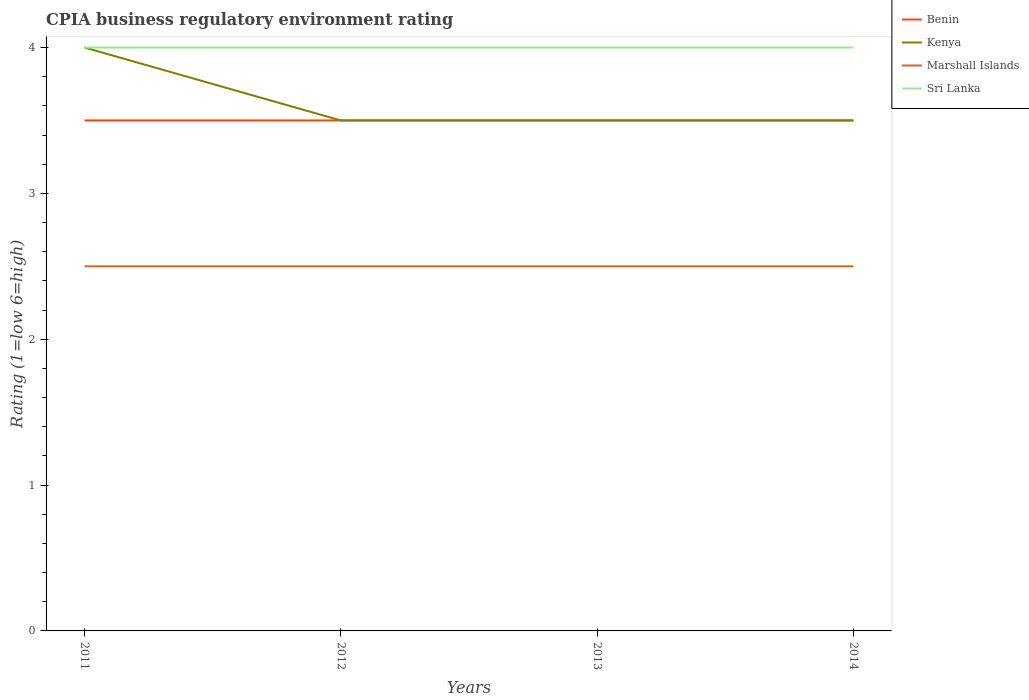How many different coloured lines are there?
Provide a succinct answer. 4. Is the number of lines equal to the number of legend labels?
Make the answer very short. Yes. Across all years, what is the maximum CPIA rating in Benin?
Offer a terse response. 3.5. What is the total CPIA rating in Marshall Islands in the graph?
Offer a very short reply. 0. How many years are there in the graph?
Provide a succinct answer. 4. Are the values on the major ticks of Y-axis written in scientific E-notation?
Ensure brevity in your answer.  No. Does the graph contain grids?
Give a very brief answer. No. How many legend labels are there?
Provide a succinct answer. 4. How are the legend labels stacked?
Offer a terse response. Vertical. What is the title of the graph?
Give a very brief answer. CPIA business regulatory environment rating. Does "Finland" appear as one of the legend labels in the graph?
Give a very brief answer. No. What is the Rating (1=low 6=high) in Benin in 2011?
Keep it short and to the point. 3.5. What is the Rating (1=low 6=high) of Kenya in 2011?
Your answer should be very brief. 4. What is the Rating (1=low 6=high) of Kenya in 2012?
Give a very brief answer. 3.5. What is the Rating (1=low 6=high) of Marshall Islands in 2012?
Give a very brief answer. 2.5. What is the Rating (1=low 6=high) in Marshall Islands in 2013?
Ensure brevity in your answer.  2.5. What is the Rating (1=low 6=high) of Sri Lanka in 2013?
Your answer should be very brief. 4. What is the Rating (1=low 6=high) of Marshall Islands in 2014?
Keep it short and to the point. 2.5. Across all years, what is the maximum Rating (1=low 6=high) in Benin?
Ensure brevity in your answer.  3.5. Across all years, what is the maximum Rating (1=low 6=high) of Kenya?
Provide a short and direct response. 4. Across all years, what is the maximum Rating (1=low 6=high) in Marshall Islands?
Provide a short and direct response. 2.5. Across all years, what is the maximum Rating (1=low 6=high) of Sri Lanka?
Give a very brief answer. 4. Across all years, what is the minimum Rating (1=low 6=high) of Kenya?
Your answer should be very brief. 3.5. Across all years, what is the minimum Rating (1=low 6=high) of Sri Lanka?
Ensure brevity in your answer.  4. What is the total Rating (1=low 6=high) in Benin in the graph?
Make the answer very short. 14. What is the total Rating (1=low 6=high) of Sri Lanka in the graph?
Your response must be concise. 16. What is the difference between the Rating (1=low 6=high) in Benin in 2011 and that in 2012?
Provide a succinct answer. 0. What is the difference between the Rating (1=low 6=high) of Sri Lanka in 2011 and that in 2012?
Your answer should be very brief. 0. What is the difference between the Rating (1=low 6=high) in Sri Lanka in 2011 and that in 2013?
Keep it short and to the point. 0. What is the difference between the Rating (1=low 6=high) of Kenya in 2011 and that in 2014?
Give a very brief answer. 0.5. What is the difference between the Rating (1=low 6=high) of Marshall Islands in 2011 and that in 2014?
Keep it short and to the point. 0. What is the difference between the Rating (1=low 6=high) of Sri Lanka in 2011 and that in 2014?
Give a very brief answer. 0. What is the difference between the Rating (1=low 6=high) in Marshall Islands in 2012 and that in 2013?
Give a very brief answer. 0. What is the difference between the Rating (1=low 6=high) of Sri Lanka in 2012 and that in 2014?
Offer a very short reply. 0. What is the difference between the Rating (1=low 6=high) in Marshall Islands in 2013 and that in 2014?
Make the answer very short. 0. What is the difference between the Rating (1=low 6=high) in Sri Lanka in 2013 and that in 2014?
Your answer should be very brief. 0. What is the difference between the Rating (1=low 6=high) in Benin in 2011 and the Rating (1=low 6=high) in Kenya in 2012?
Your answer should be compact. 0. What is the difference between the Rating (1=low 6=high) of Benin in 2011 and the Rating (1=low 6=high) of Marshall Islands in 2012?
Your response must be concise. 1. What is the difference between the Rating (1=low 6=high) of Benin in 2011 and the Rating (1=low 6=high) of Sri Lanka in 2012?
Offer a very short reply. -0.5. What is the difference between the Rating (1=low 6=high) in Kenya in 2011 and the Rating (1=low 6=high) in Marshall Islands in 2012?
Keep it short and to the point. 1.5. What is the difference between the Rating (1=low 6=high) of Kenya in 2011 and the Rating (1=low 6=high) of Sri Lanka in 2012?
Your response must be concise. 0. What is the difference between the Rating (1=low 6=high) of Marshall Islands in 2011 and the Rating (1=low 6=high) of Sri Lanka in 2012?
Make the answer very short. -1.5. What is the difference between the Rating (1=low 6=high) in Benin in 2011 and the Rating (1=low 6=high) in Kenya in 2013?
Your response must be concise. 0. What is the difference between the Rating (1=low 6=high) of Benin in 2011 and the Rating (1=low 6=high) of Marshall Islands in 2013?
Provide a succinct answer. 1. What is the difference between the Rating (1=low 6=high) of Benin in 2011 and the Rating (1=low 6=high) of Sri Lanka in 2013?
Provide a short and direct response. -0.5. What is the difference between the Rating (1=low 6=high) in Marshall Islands in 2011 and the Rating (1=low 6=high) in Sri Lanka in 2013?
Offer a very short reply. -1.5. What is the difference between the Rating (1=low 6=high) of Benin in 2011 and the Rating (1=low 6=high) of Kenya in 2014?
Provide a succinct answer. 0. What is the difference between the Rating (1=low 6=high) of Benin in 2011 and the Rating (1=low 6=high) of Sri Lanka in 2014?
Offer a terse response. -0.5. What is the difference between the Rating (1=low 6=high) of Kenya in 2011 and the Rating (1=low 6=high) of Marshall Islands in 2014?
Keep it short and to the point. 1.5. What is the difference between the Rating (1=low 6=high) of Benin in 2012 and the Rating (1=low 6=high) of Kenya in 2013?
Make the answer very short. 0. What is the difference between the Rating (1=low 6=high) in Benin in 2012 and the Rating (1=low 6=high) in Sri Lanka in 2013?
Make the answer very short. -0.5. What is the difference between the Rating (1=low 6=high) of Marshall Islands in 2012 and the Rating (1=low 6=high) of Sri Lanka in 2013?
Provide a succinct answer. -1.5. What is the difference between the Rating (1=low 6=high) of Benin in 2012 and the Rating (1=low 6=high) of Kenya in 2014?
Your response must be concise. 0. What is the difference between the Rating (1=low 6=high) of Benin in 2012 and the Rating (1=low 6=high) of Sri Lanka in 2014?
Offer a very short reply. -0.5. What is the difference between the Rating (1=low 6=high) of Kenya in 2012 and the Rating (1=low 6=high) of Marshall Islands in 2014?
Your answer should be very brief. 1. What is the difference between the Rating (1=low 6=high) in Kenya in 2012 and the Rating (1=low 6=high) in Sri Lanka in 2014?
Offer a terse response. -0.5. What is the difference between the Rating (1=low 6=high) of Benin in 2013 and the Rating (1=low 6=high) of Kenya in 2014?
Provide a short and direct response. 0. What is the difference between the Rating (1=low 6=high) of Benin in 2013 and the Rating (1=low 6=high) of Marshall Islands in 2014?
Ensure brevity in your answer.  1. What is the difference between the Rating (1=low 6=high) of Marshall Islands in 2013 and the Rating (1=low 6=high) of Sri Lanka in 2014?
Your answer should be very brief. -1.5. What is the average Rating (1=low 6=high) of Kenya per year?
Your response must be concise. 3.62. In the year 2011, what is the difference between the Rating (1=low 6=high) in Kenya and Rating (1=low 6=high) in Sri Lanka?
Give a very brief answer. 0. In the year 2011, what is the difference between the Rating (1=low 6=high) of Marshall Islands and Rating (1=low 6=high) of Sri Lanka?
Keep it short and to the point. -1.5. In the year 2012, what is the difference between the Rating (1=low 6=high) of Benin and Rating (1=low 6=high) of Marshall Islands?
Offer a very short reply. 1. In the year 2012, what is the difference between the Rating (1=low 6=high) of Benin and Rating (1=low 6=high) of Sri Lanka?
Your answer should be compact. -0.5. In the year 2012, what is the difference between the Rating (1=low 6=high) in Marshall Islands and Rating (1=low 6=high) in Sri Lanka?
Keep it short and to the point. -1.5. In the year 2013, what is the difference between the Rating (1=low 6=high) of Benin and Rating (1=low 6=high) of Kenya?
Give a very brief answer. 0. In the year 2013, what is the difference between the Rating (1=low 6=high) in Benin and Rating (1=low 6=high) in Sri Lanka?
Your answer should be compact. -0.5. In the year 2013, what is the difference between the Rating (1=low 6=high) in Kenya and Rating (1=low 6=high) in Marshall Islands?
Offer a terse response. 1. In the year 2014, what is the difference between the Rating (1=low 6=high) in Kenya and Rating (1=low 6=high) in Marshall Islands?
Your response must be concise. 1. In the year 2014, what is the difference between the Rating (1=low 6=high) in Kenya and Rating (1=low 6=high) in Sri Lanka?
Your answer should be compact. -0.5. What is the ratio of the Rating (1=low 6=high) of Marshall Islands in 2011 to that in 2012?
Keep it short and to the point. 1. What is the ratio of the Rating (1=low 6=high) of Sri Lanka in 2011 to that in 2012?
Ensure brevity in your answer.  1. What is the ratio of the Rating (1=low 6=high) in Kenya in 2011 to that in 2013?
Keep it short and to the point. 1.14. What is the ratio of the Rating (1=low 6=high) in Sri Lanka in 2011 to that in 2013?
Provide a short and direct response. 1. What is the ratio of the Rating (1=low 6=high) of Benin in 2011 to that in 2014?
Offer a very short reply. 1. What is the ratio of the Rating (1=low 6=high) of Kenya in 2011 to that in 2014?
Your answer should be very brief. 1.14. What is the ratio of the Rating (1=low 6=high) in Benin in 2012 to that in 2014?
Keep it short and to the point. 1. What is the ratio of the Rating (1=low 6=high) of Sri Lanka in 2012 to that in 2014?
Keep it short and to the point. 1. What is the ratio of the Rating (1=low 6=high) of Benin in 2013 to that in 2014?
Your answer should be compact. 1. What is the ratio of the Rating (1=low 6=high) of Kenya in 2013 to that in 2014?
Offer a terse response. 1. What is the ratio of the Rating (1=low 6=high) in Marshall Islands in 2013 to that in 2014?
Your answer should be very brief. 1. What is the ratio of the Rating (1=low 6=high) in Sri Lanka in 2013 to that in 2014?
Offer a terse response. 1. What is the difference between the highest and the second highest Rating (1=low 6=high) of Benin?
Ensure brevity in your answer.  0. What is the difference between the highest and the second highest Rating (1=low 6=high) of Marshall Islands?
Your response must be concise. 0. What is the difference between the highest and the lowest Rating (1=low 6=high) in Kenya?
Offer a very short reply. 0.5. What is the difference between the highest and the lowest Rating (1=low 6=high) of Marshall Islands?
Offer a terse response. 0. 